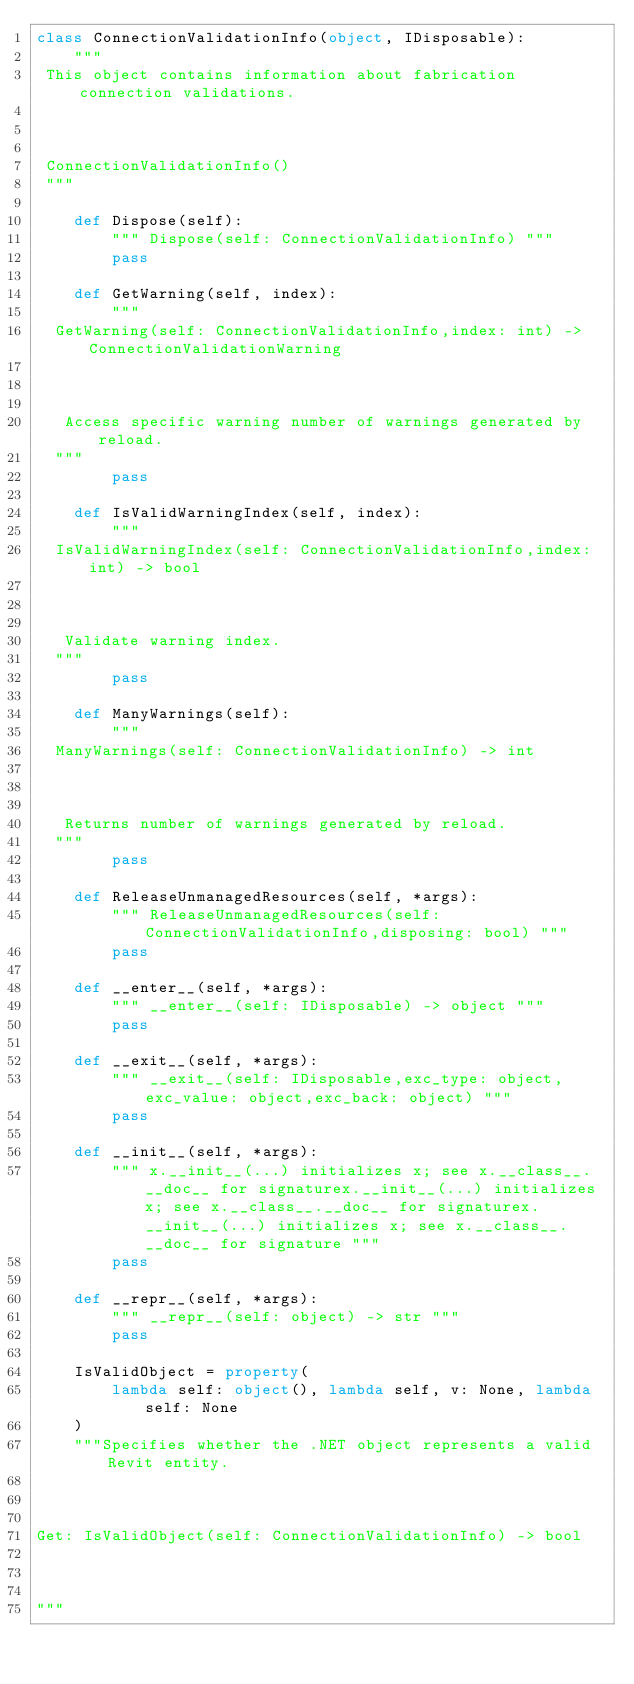Convert code to text. <code><loc_0><loc_0><loc_500><loc_500><_Python_>class ConnectionValidationInfo(object, IDisposable):
    """
 This object contains information about fabrication connection validations.

 

 ConnectionValidationInfo()
 """

    def Dispose(self):
        """ Dispose(self: ConnectionValidationInfo) """
        pass

    def GetWarning(self, index):
        """
  GetWarning(self: ConnectionValidationInfo,index: int) -> ConnectionValidationWarning

  

   Access specific warning number of warnings generated by reload.
  """
        pass

    def IsValidWarningIndex(self, index):
        """
  IsValidWarningIndex(self: ConnectionValidationInfo,index: int) -> bool

  

   Validate warning index.
  """
        pass

    def ManyWarnings(self):
        """
  ManyWarnings(self: ConnectionValidationInfo) -> int

  

   Returns number of warnings generated by reload.
  """
        pass

    def ReleaseUnmanagedResources(self, *args):
        """ ReleaseUnmanagedResources(self: ConnectionValidationInfo,disposing: bool) """
        pass

    def __enter__(self, *args):
        """ __enter__(self: IDisposable) -> object """
        pass

    def __exit__(self, *args):
        """ __exit__(self: IDisposable,exc_type: object,exc_value: object,exc_back: object) """
        pass

    def __init__(self, *args):
        """ x.__init__(...) initializes x; see x.__class__.__doc__ for signaturex.__init__(...) initializes x; see x.__class__.__doc__ for signaturex.__init__(...) initializes x; see x.__class__.__doc__ for signature """
        pass

    def __repr__(self, *args):
        """ __repr__(self: object) -> str """
        pass

    IsValidObject = property(
        lambda self: object(), lambda self, v: None, lambda self: None
    )
    """Specifies whether the .NET object represents a valid Revit entity.



Get: IsValidObject(self: ConnectionValidationInfo) -> bool



"""
</code> 